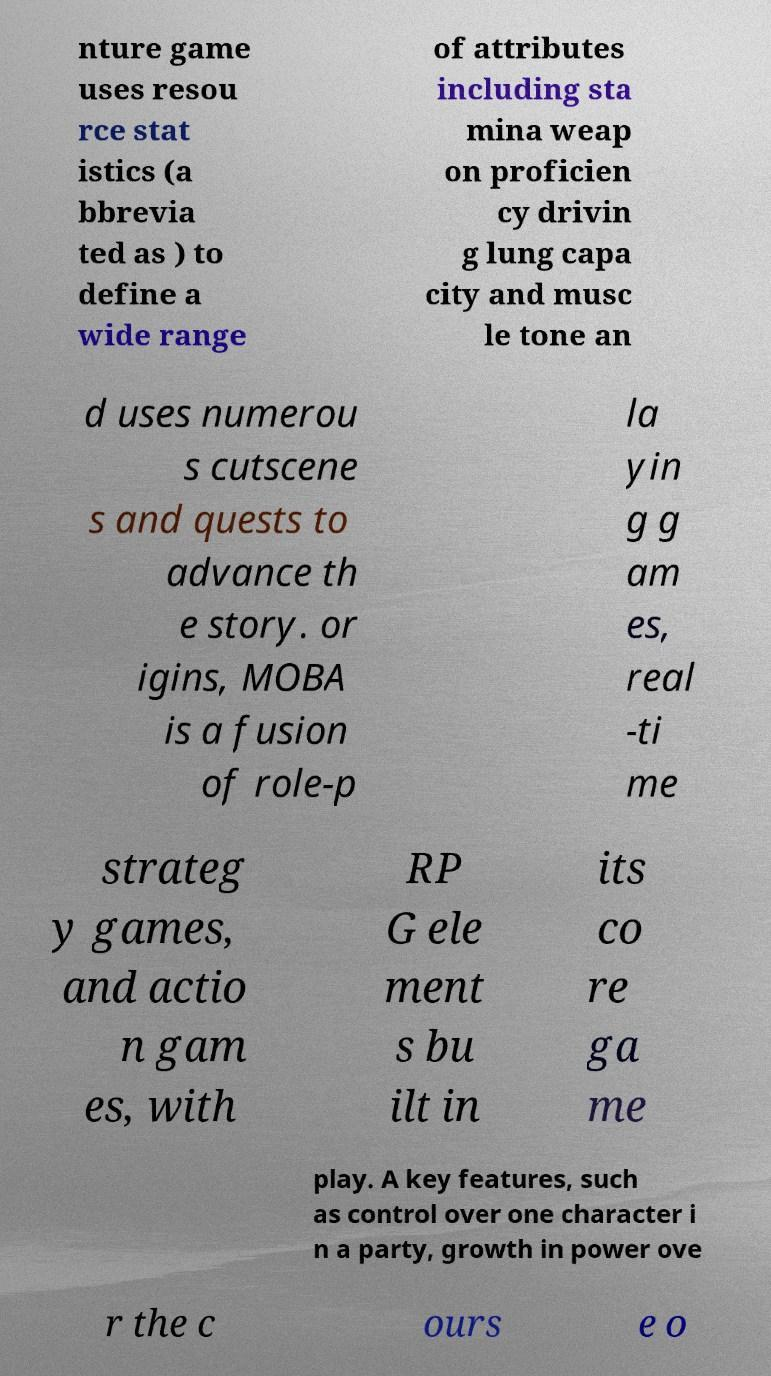Could you extract and type out the text from this image? nture game uses resou rce stat istics (a bbrevia ted as ) to define a wide range of attributes including sta mina weap on proficien cy drivin g lung capa city and musc le tone an d uses numerou s cutscene s and quests to advance th e story. or igins, MOBA is a fusion of role-p la yin g g am es, real -ti me strateg y games, and actio n gam es, with RP G ele ment s bu ilt in its co re ga me play. A key features, such as control over one character i n a party, growth in power ove r the c ours e o 